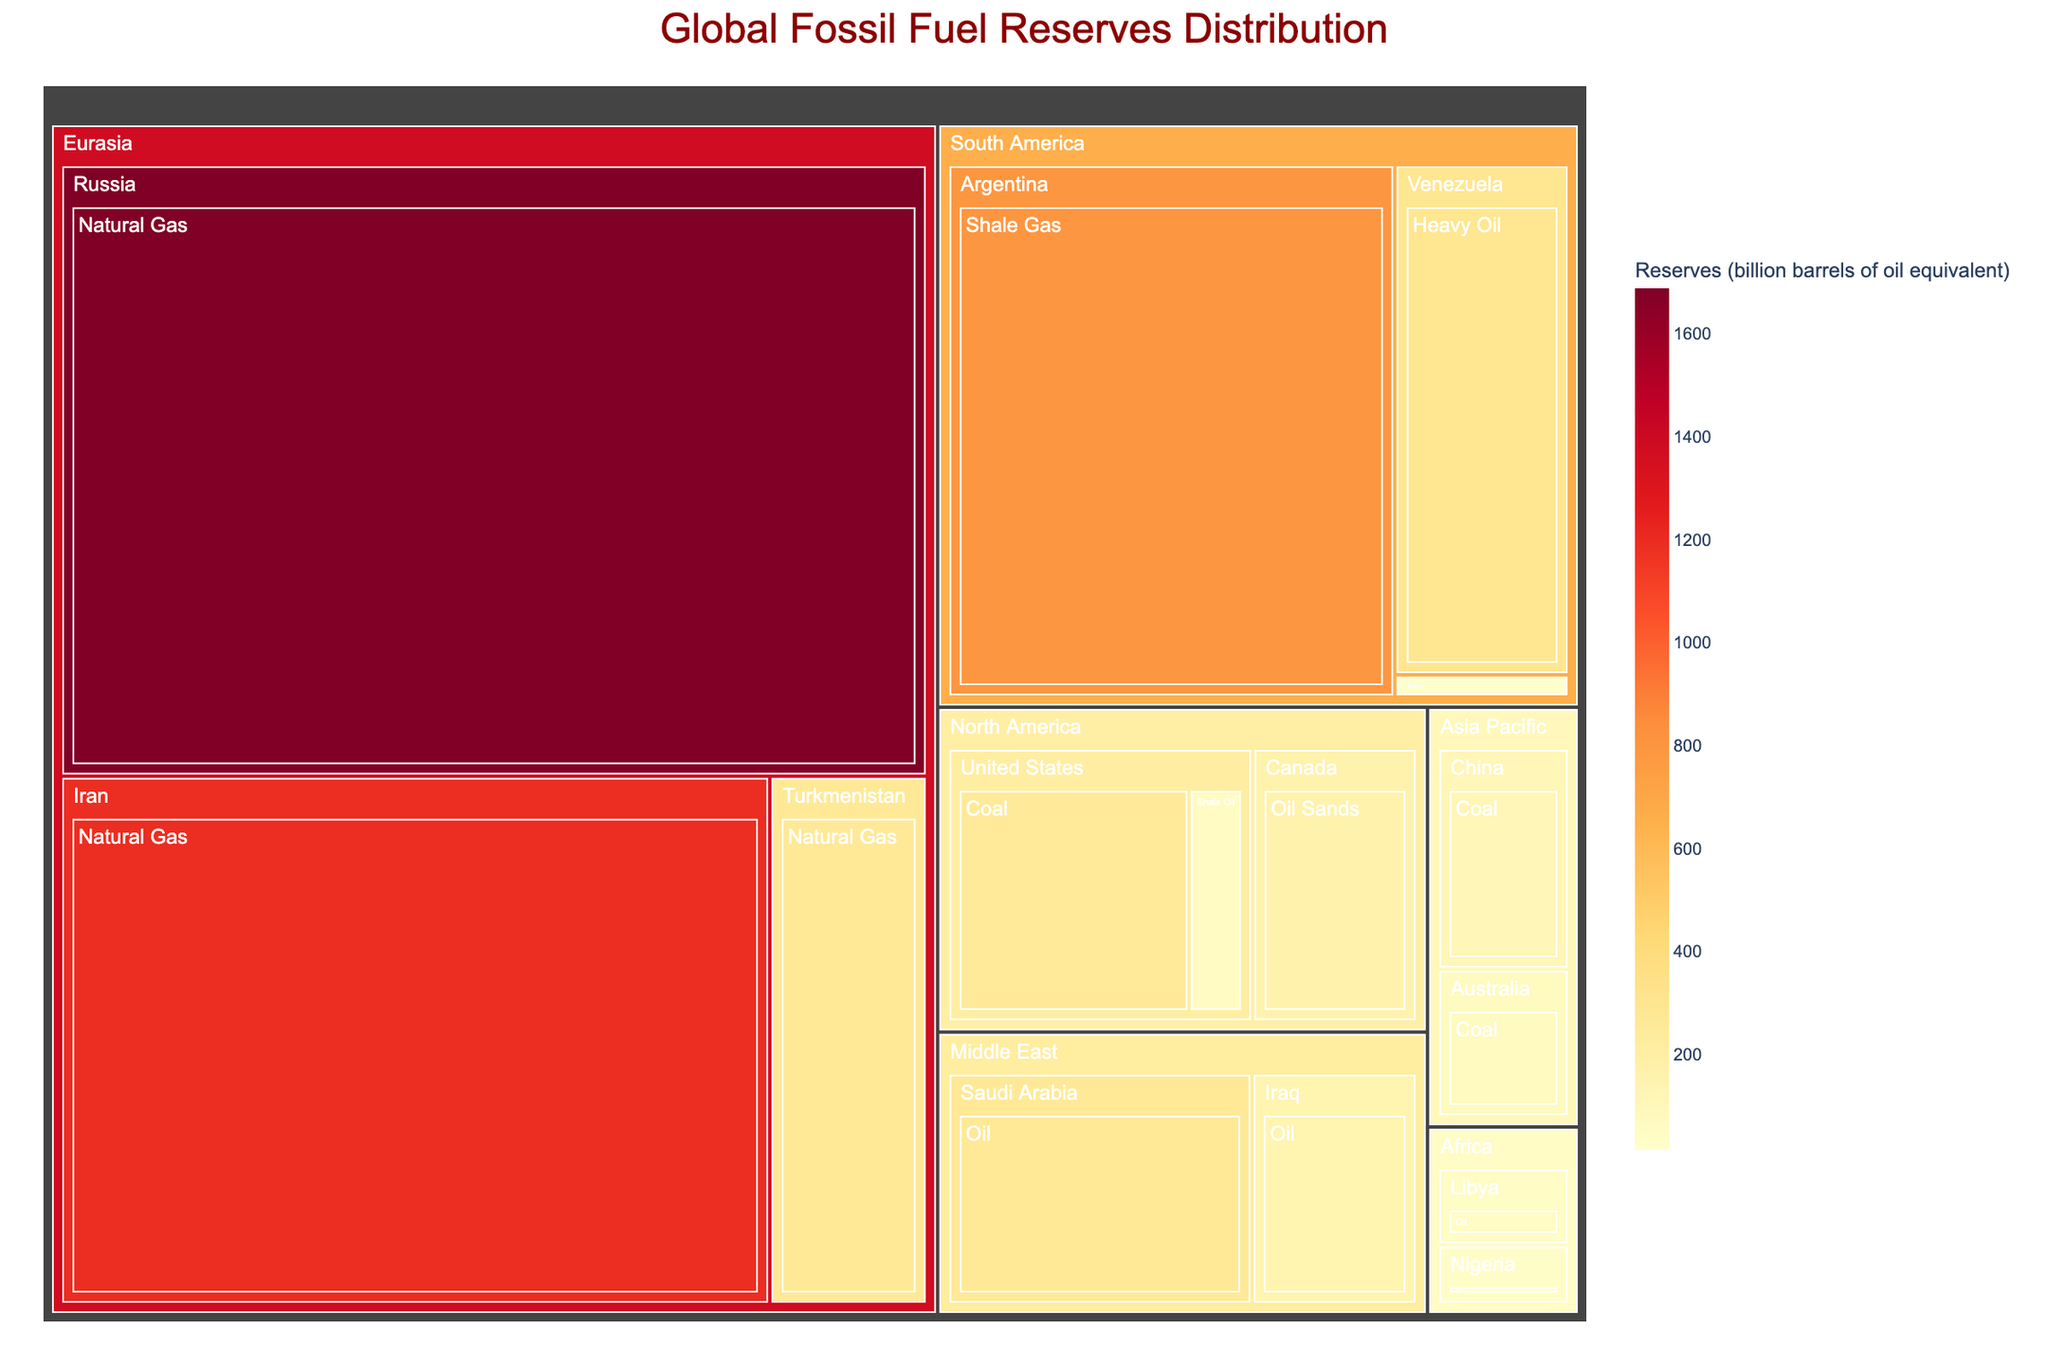What is the title of the treemap? The title is displayed at the top center of the treemap in a large font, indicating the subject of the visualization.
Answer: Global Fossil Fuel Reserves Distribution Which region has the largest fossil fuel reserves? By observing the regions and comparing the size of their blocks, we can identify the region with the largest area.
Answer: Eurasia How many types of fossil fuels are represented in the treemap? By counting the different categories under "Fossil Fuel Type" within the treemap, we can determine the total number of types.
Answer: 6 What is the reserve amount for shale gas in Argentina? Locate the block for Argentina under the South America region and check the reserves value for shale gas.
Answer: 802 billion barrels Compare the oil reserves of Saudi Arabia and Iraq. Which country has more? Find the oil reserves for both Saudi Arabia (267) and Iraq (145) and compare these values.
Answer: Saudi Arabia What is the difference in natural gas reserves between Russia and Iran? Identify the natural gas reserves for Russia (1688) and Iran (1193), then subtract Iran's reserves from Russia's.
Answer: 495 billion barrels Which country in North America has oil sands reserves? Look under the North America region and find the country listed with oil sands reserves.
Answer: Canada What is the sum of coal reserves in the Asia Pacific region? Add the coal reserves of China (114) and Australia (76) found in the Asia Pacific region.
Answer: 190 billion barrels List the countries in the Africa region along with their fossil fuel types. Identify the blocks under the Africa region and list the countries with their respective fossil fuel types.
Answer: Nigeria (Oil), Libya (Oil) Which region outside of Eurasia has significant natural gas reserves, and how much? Scan the regions other than Eurasia and find any notable natural gas reserves, then identify the amount.
Answer: South America, Argentina (802 billion barrels) 